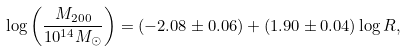<formula> <loc_0><loc_0><loc_500><loc_500>\log \left ( \frac { M _ { 2 0 0 } } { 1 0 ^ { 1 4 } M _ { \odot } } \right ) = ( - 2 . 0 8 \pm 0 . 0 6 ) + ( 1 . 9 0 \pm 0 . 0 4 ) \log R ,</formula> 